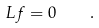Convert formula to latex. <formula><loc_0><loc_0><loc_500><loc_500>L f = 0 \quad .</formula> 